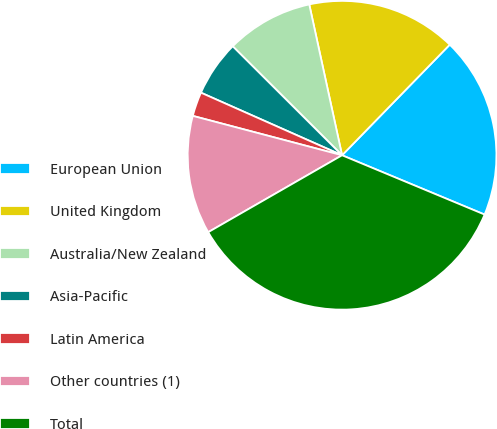Convert chart to OTSL. <chart><loc_0><loc_0><loc_500><loc_500><pie_chart><fcel>European Union<fcel>United Kingdom<fcel>Australia/New Zealand<fcel>Asia-Pacific<fcel>Latin America<fcel>Other countries (1)<fcel>Total<nl><fcel>18.99%<fcel>15.7%<fcel>9.12%<fcel>5.83%<fcel>2.54%<fcel>12.41%<fcel>35.43%<nl></chart> 